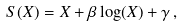<formula> <loc_0><loc_0><loc_500><loc_500>S ( X ) = X + \beta \log ( X ) + \gamma \, ,</formula> 